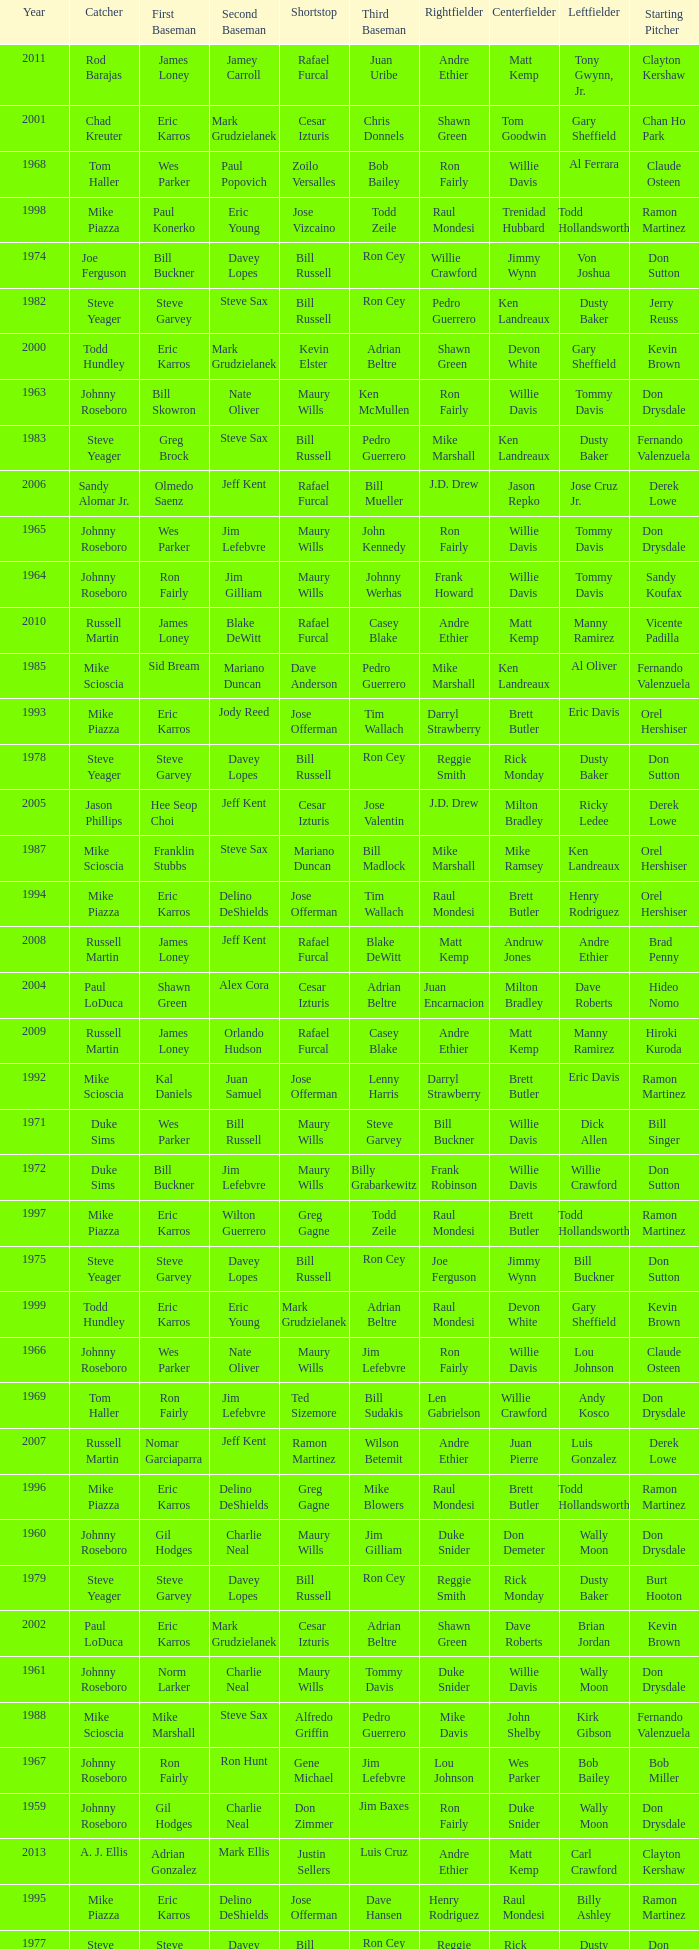Who played 2nd base when nomar garciaparra was at 1st base? Jeff Kent. 